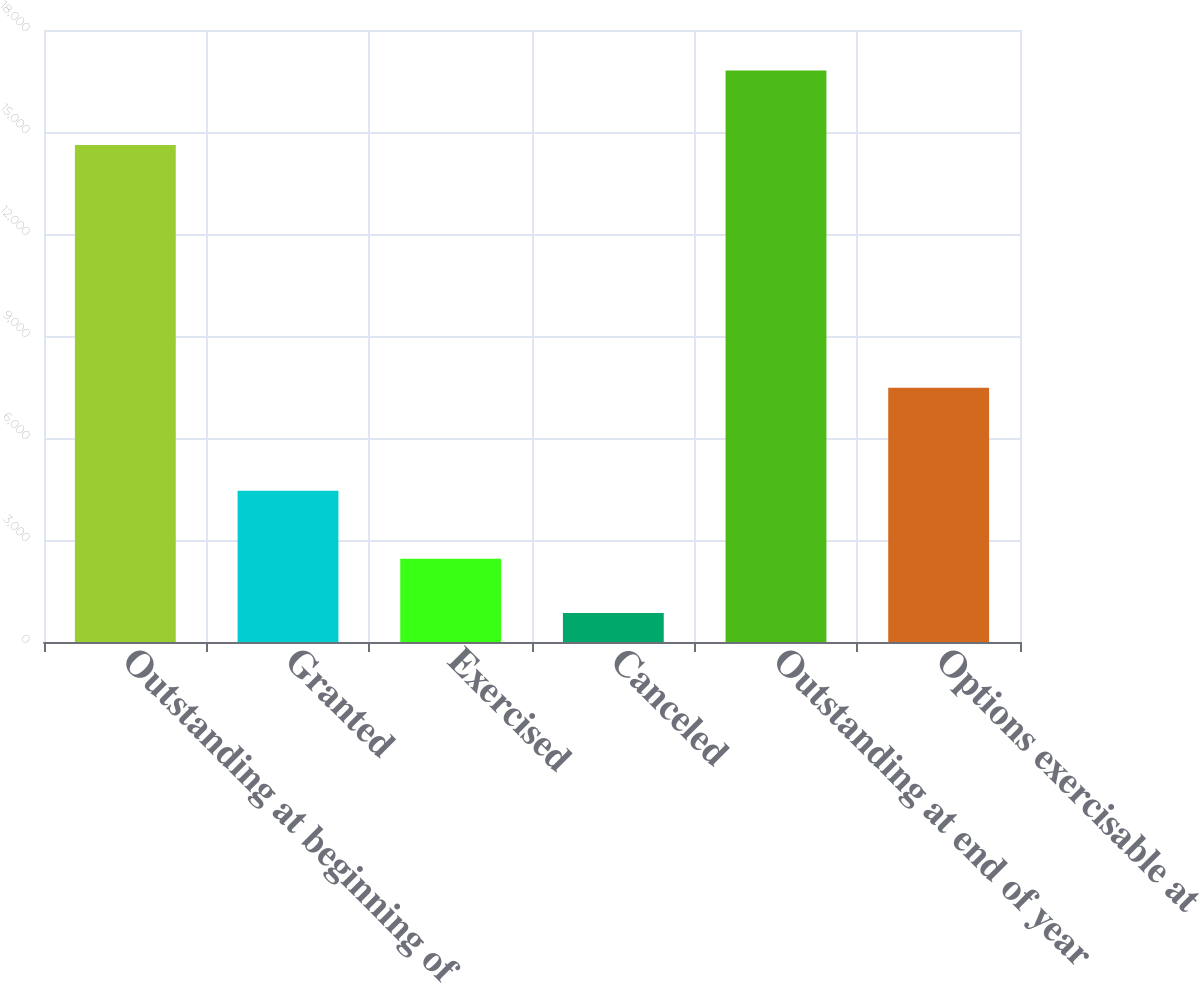Convert chart to OTSL. <chart><loc_0><loc_0><loc_500><loc_500><bar_chart><fcel>Outstanding at beginning of<fcel>Granted<fcel>Exercised<fcel>Canceled<fcel>Outstanding at end of year<fcel>Options exercisable at<nl><fcel>14615<fcel>4451<fcel>2450.5<fcel>855<fcel>16810<fcel>7476<nl></chart> 